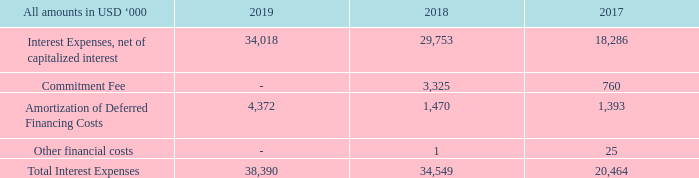11. INTEREST EXPENSES
Interest expenses consist of interest expense on the long-term debt, the commitment fee and amortization of deferred financing costs related to the Credit Facility described in Note 9.
For the years ended December 31, 2019, 2018 and 2017, $0.0 million, $2.6 million and $2.5 million of interest expenses were capitalized, respectively.
What are the respective interest expenses capitalised in the years ended December 31, 2019 and 2018? $0.0 million, $2.6 million. What are the respective interest expenses capitalised in the years ended December 31, 2018 and 2017? $2.6 million, $2.5 million. What are the respective interest expenses net of capitalised interest in 2018 and 2019?
Answer scale should be: thousand. 29,753, 34,018. What is the percentage change in the interest expense, net of capitalised interest between 2017 and 2018?
Answer scale should be: percent. (29,753 - 18,286)/18,286 
Answer: 62.71. What is the percentage change in the interest expense, net of capitalised interest between 2018 and 2019?
Answer scale should be: percent. (34,018 - 29,753)/29,753 
Answer: 14.33. What is the percentage change in the total interest expense between 2018 and 2019?
Answer scale should be: percent. (38,390 - 34,549)/34,549 
Answer: 11.12. 